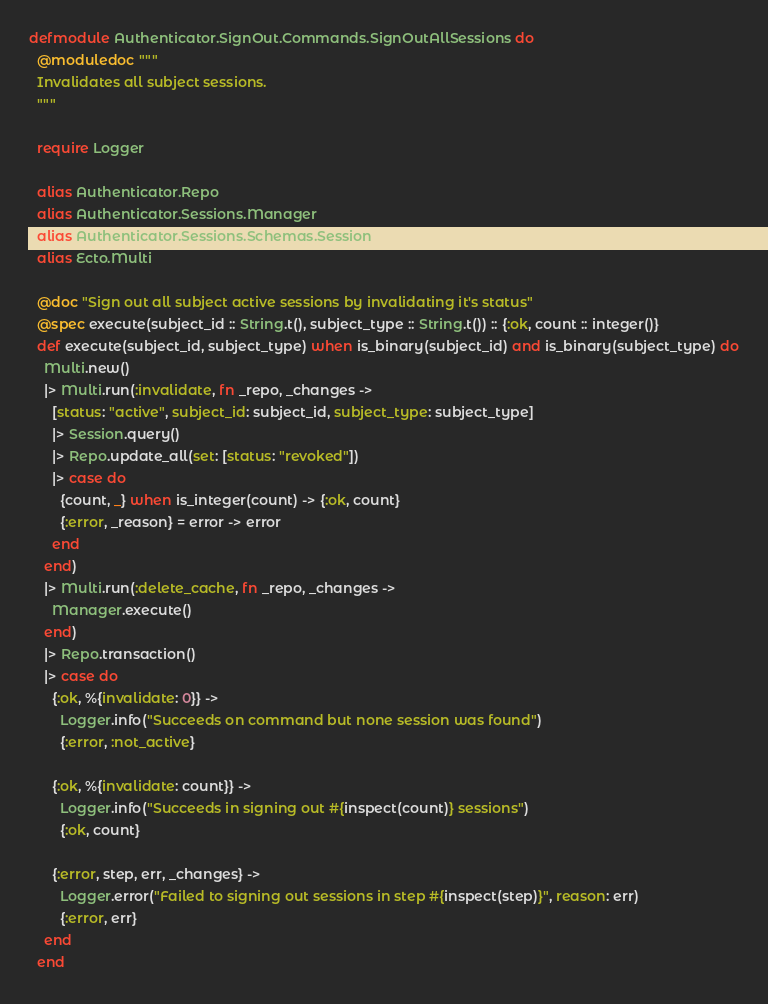Convert code to text. <code><loc_0><loc_0><loc_500><loc_500><_Elixir_>defmodule Authenticator.SignOut.Commands.SignOutAllSessions do
  @moduledoc """
  Invalidates all subject sessions.
  """

  require Logger

  alias Authenticator.Repo
  alias Authenticator.Sessions.Manager
  alias Authenticator.Sessions.Schemas.Session
  alias Ecto.Multi

  @doc "Sign out all subject active sessions by invalidating it's status"
  @spec execute(subject_id :: String.t(), subject_type :: String.t()) :: {:ok, count :: integer()}
  def execute(subject_id, subject_type) when is_binary(subject_id) and is_binary(subject_type) do
    Multi.new()
    |> Multi.run(:invalidate, fn _repo, _changes ->
      [status: "active", subject_id: subject_id, subject_type: subject_type]
      |> Session.query()
      |> Repo.update_all(set: [status: "revoked"])
      |> case do
        {count, _} when is_integer(count) -> {:ok, count}
        {:error, _reason} = error -> error
      end
    end)
    |> Multi.run(:delete_cache, fn _repo, _changes ->
      Manager.execute()
    end)
    |> Repo.transaction()
    |> case do
      {:ok, %{invalidate: 0}} ->
        Logger.info("Succeeds on command but none session was found")
        {:error, :not_active}

      {:ok, %{invalidate: count}} ->
        Logger.info("Succeeds in signing out #{inspect(count)} sessions")
        {:ok, count}

      {:error, step, err, _changes} ->
        Logger.error("Failed to signing out sessions in step #{inspect(step)}", reason: err)
        {:error, err}
    end
  end
</code> 